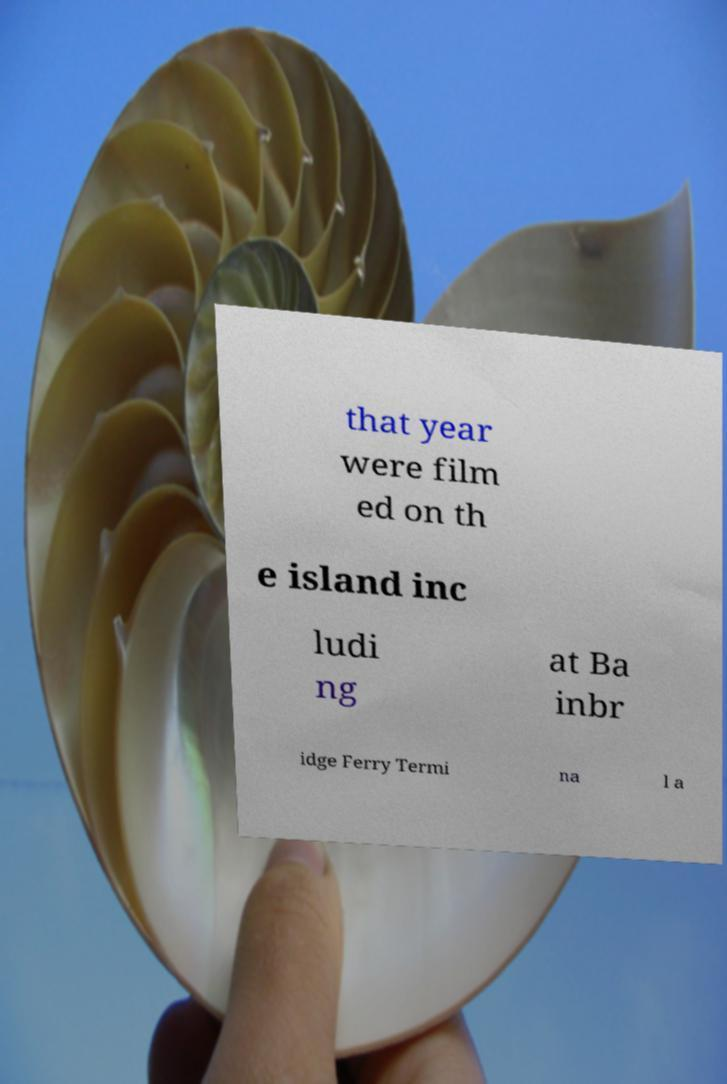Could you assist in decoding the text presented in this image and type it out clearly? that year were film ed on th e island inc ludi ng at Ba inbr idge Ferry Termi na l a 